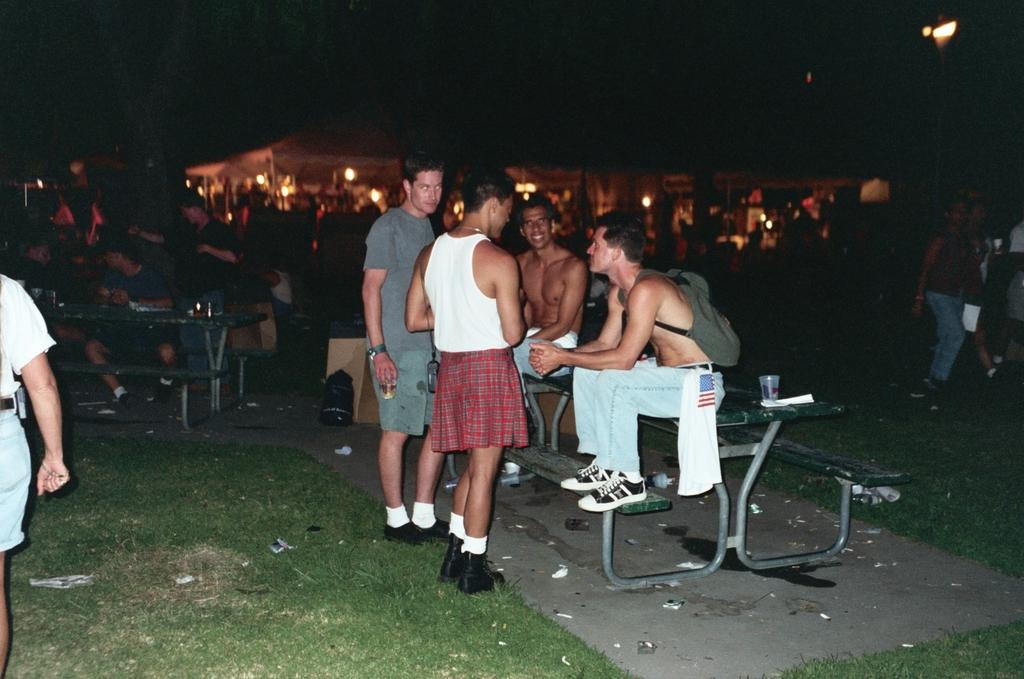How many people are in the image? There is a group of people in the image, but the exact number cannot be determined from the provided facts. What type of furniture is present in the image? There are tables in the image. What objects are used for drinking in the image? There are glasses in the image. What type of illumination is present in the image? There are lights in the image. What type of natural environment is visible in the image? There is grass in the image. What type of structures can be seen in the background of the image? There are buildings in the background of the image. How would you describe the lighting conditions in the image? The image is slightly dark. What type of plot is being discussed by the people in the image? There is no indication in the image that the people are discussing a plot, as the provided facts do not mention any conversation or topic. What type of pie is being served on the tables in the image? There is no pie present in the image; only glasses, tables, and a group of people are mentioned. 